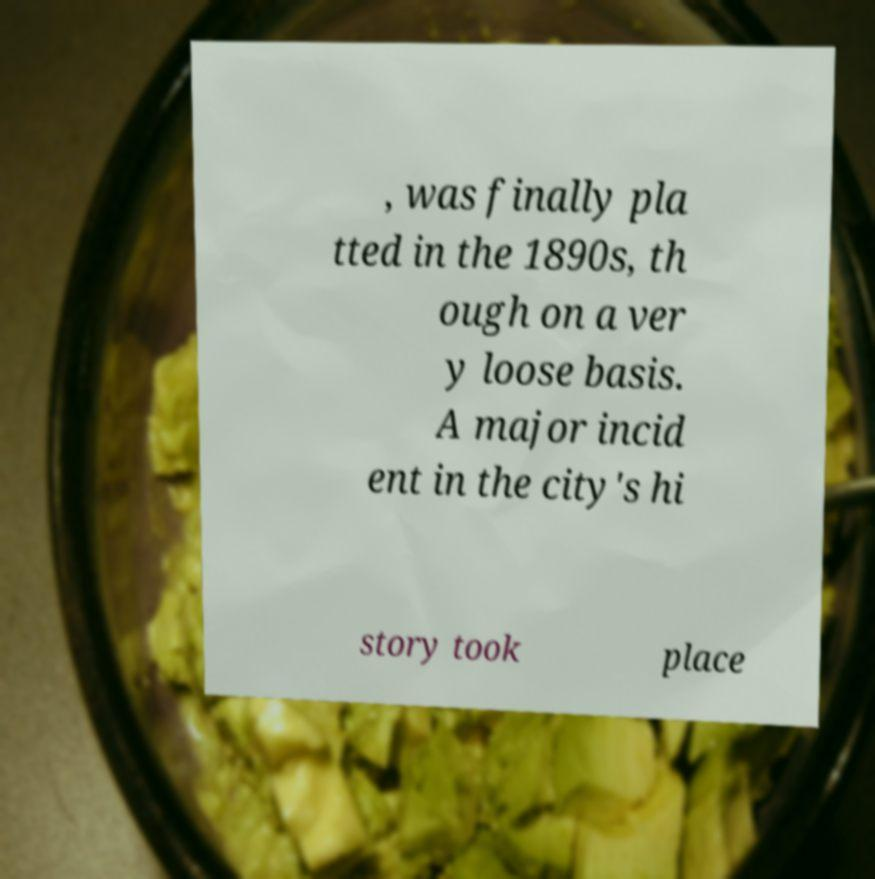Can you read and provide the text displayed in the image?This photo seems to have some interesting text. Can you extract and type it out for me? , was finally pla tted in the 1890s, th ough on a ver y loose basis. A major incid ent in the city's hi story took place 